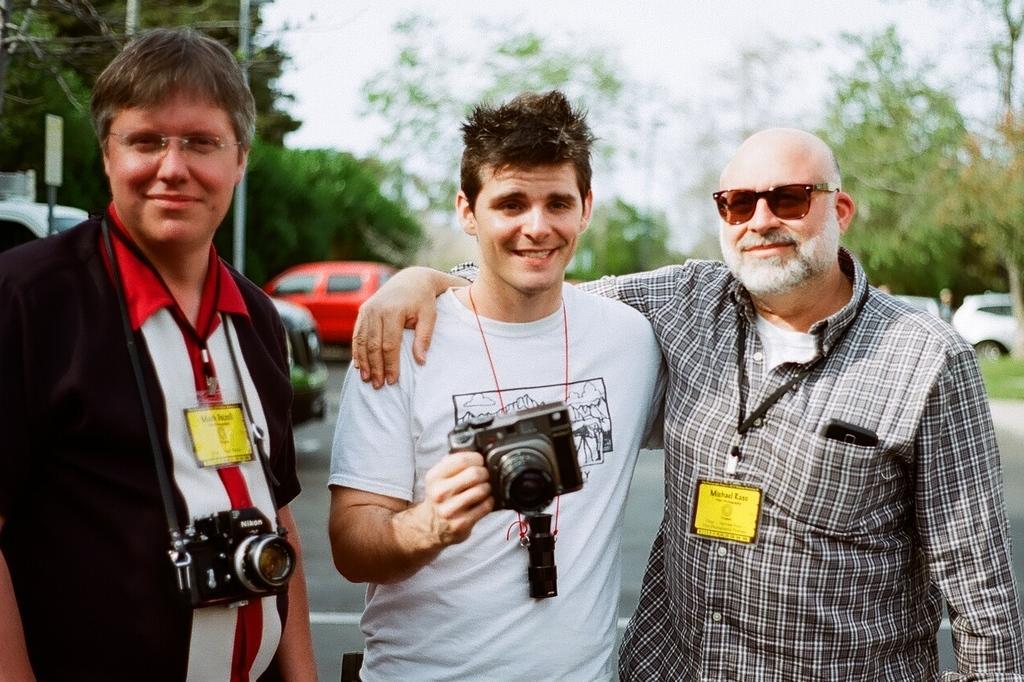In one or two sentences, can you explain what this image depicts? In this image in the front there are persons standing and smiling. In the center there is a man standing and holding a camera and smiling. In the background there are cars, trees, poles and there's grass on the ground. 